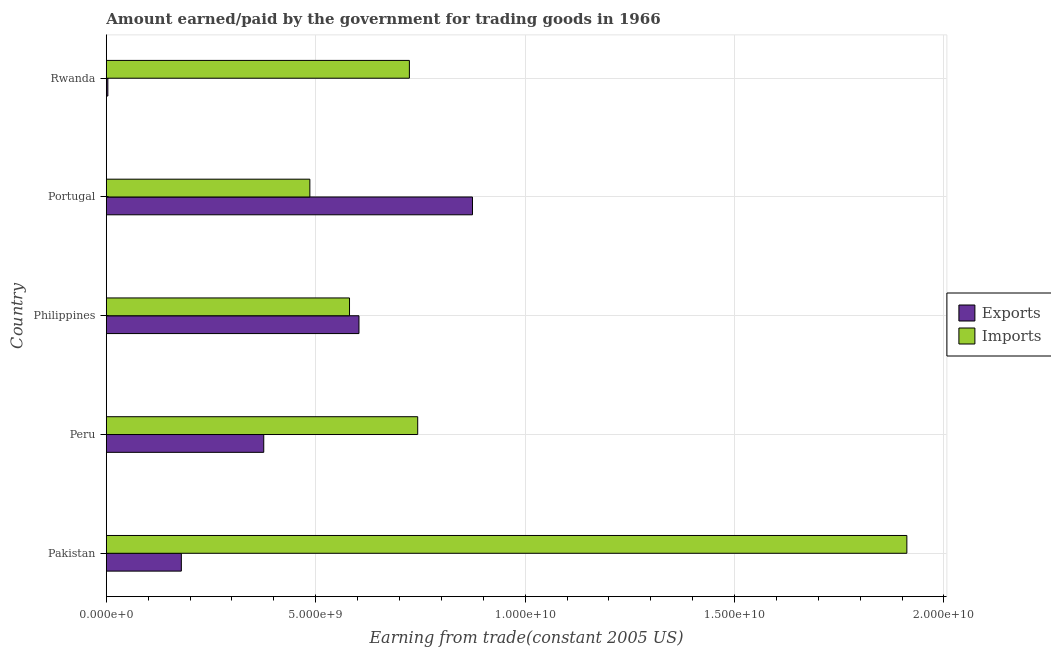How many groups of bars are there?
Your answer should be very brief. 5. Are the number of bars per tick equal to the number of legend labels?
Ensure brevity in your answer.  Yes. How many bars are there on the 5th tick from the top?
Provide a succinct answer. 2. How many bars are there on the 1st tick from the bottom?
Your answer should be very brief. 2. What is the amount paid for imports in Peru?
Ensure brevity in your answer.  7.43e+09. Across all countries, what is the maximum amount earned from exports?
Your answer should be compact. 8.74e+09. Across all countries, what is the minimum amount paid for imports?
Make the answer very short. 4.86e+09. In which country was the amount earned from exports maximum?
Offer a terse response. Portugal. In which country was the amount earned from exports minimum?
Give a very brief answer. Rwanda. What is the total amount earned from exports in the graph?
Offer a very short reply. 2.04e+1. What is the difference between the amount paid for imports in Philippines and that in Rwanda?
Your answer should be very brief. -1.43e+09. What is the difference between the amount paid for imports in Peru and the amount earned from exports in Portugal?
Your answer should be compact. -1.31e+09. What is the average amount paid for imports per country?
Keep it short and to the point. 8.89e+09. What is the difference between the amount paid for imports and amount earned from exports in Philippines?
Your response must be concise. -2.26e+08. In how many countries, is the amount paid for imports greater than 2000000000 US$?
Provide a succinct answer. 5. What is the ratio of the amount earned from exports in Pakistan to that in Philippines?
Offer a very short reply. 0.3. What is the difference between the highest and the second highest amount earned from exports?
Offer a terse response. 2.71e+09. What is the difference between the highest and the lowest amount paid for imports?
Provide a succinct answer. 1.43e+1. In how many countries, is the amount paid for imports greater than the average amount paid for imports taken over all countries?
Provide a short and direct response. 1. Is the sum of the amount earned from exports in Peru and Philippines greater than the maximum amount paid for imports across all countries?
Provide a short and direct response. No. What does the 1st bar from the top in Pakistan represents?
Offer a very short reply. Imports. What does the 2nd bar from the bottom in Philippines represents?
Offer a terse response. Imports. How many bars are there?
Give a very brief answer. 10. Are all the bars in the graph horizontal?
Keep it short and to the point. Yes. What is the difference between two consecutive major ticks on the X-axis?
Ensure brevity in your answer.  5.00e+09. Are the values on the major ticks of X-axis written in scientific E-notation?
Give a very brief answer. Yes. Where does the legend appear in the graph?
Your response must be concise. Center right. How are the legend labels stacked?
Offer a very short reply. Vertical. What is the title of the graph?
Provide a succinct answer. Amount earned/paid by the government for trading goods in 1966. What is the label or title of the X-axis?
Offer a very short reply. Earning from trade(constant 2005 US). What is the label or title of the Y-axis?
Ensure brevity in your answer.  Country. What is the Earning from trade(constant 2005 US) in Exports in Pakistan?
Offer a very short reply. 1.79e+09. What is the Earning from trade(constant 2005 US) in Imports in Pakistan?
Offer a very short reply. 1.91e+1. What is the Earning from trade(constant 2005 US) in Exports in Peru?
Your response must be concise. 3.76e+09. What is the Earning from trade(constant 2005 US) of Imports in Peru?
Ensure brevity in your answer.  7.43e+09. What is the Earning from trade(constant 2005 US) of Exports in Philippines?
Ensure brevity in your answer.  6.03e+09. What is the Earning from trade(constant 2005 US) of Imports in Philippines?
Your answer should be very brief. 5.81e+09. What is the Earning from trade(constant 2005 US) of Exports in Portugal?
Give a very brief answer. 8.74e+09. What is the Earning from trade(constant 2005 US) in Imports in Portugal?
Provide a succinct answer. 4.86e+09. What is the Earning from trade(constant 2005 US) in Exports in Rwanda?
Keep it short and to the point. 3.65e+07. What is the Earning from trade(constant 2005 US) in Imports in Rwanda?
Offer a terse response. 7.24e+09. Across all countries, what is the maximum Earning from trade(constant 2005 US) of Exports?
Your response must be concise. 8.74e+09. Across all countries, what is the maximum Earning from trade(constant 2005 US) in Imports?
Your answer should be compact. 1.91e+1. Across all countries, what is the minimum Earning from trade(constant 2005 US) in Exports?
Provide a succinct answer. 3.65e+07. Across all countries, what is the minimum Earning from trade(constant 2005 US) of Imports?
Ensure brevity in your answer.  4.86e+09. What is the total Earning from trade(constant 2005 US) in Exports in the graph?
Ensure brevity in your answer.  2.04e+1. What is the total Earning from trade(constant 2005 US) in Imports in the graph?
Ensure brevity in your answer.  4.45e+1. What is the difference between the Earning from trade(constant 2005 US) of Exports in Pakistan and that in Peru?
Provide a succinct answer. -1.97e+09. What is the difference between the Earning from trade(constant 2005 US) in Imports in Pakistan and that in Peru?
Provide a succinct answer. 1.17e+1. What is the difference between the Earning from trade(constant 2005 US) in Exports in Pakistan and that in Philippines?
Offer a terse response. -4.24e+09. What is the difference between the Earning from trade(constant 2005 US) in Imports in Pakistan and that in Philippines?
Your response must be concise. 1.33e+1. What is the difference between the Earning from trade(constant 2005 US) of Exports in Pakistan and that in Portugal?
Give a very brief answer. -6.95e+09. What is the difference between the Earning from trade(constant 2005 US) in Imports in Pakistan and that in Portugal?
Offer a very short reply. 1.43e+1. What is the difference between the Earning from trade(constant 2005 US) of Exports in Pakistan and that in Rwanda?
Ensure brevity in your answer.  1.75e+09. What is the difference between the Earning from trade(constant 2005 US) in Imports in Pakistan and that in Rwanda?
Give a very brief answer. 1.19e+1. What is the difference between the Earning from trade(constant 2005 US) in Exports in Peru and that in Philippines?
Offer a terse response. -2.27e+09. What is the difference between the Earning from trade(constant 2005 US) in Imports in Peru and that in Philippines?
Provide a short and direct response. 1.63e+09. What is the difference between the Earning from trade(constant 2005 US) in Exports in Peru and that in Portugal?
Provide a short and direct response. -4.98e+09. What is the difference between the Earning from trade(constant 2005 US) of Imports in Peru and that in Portugal?
Offer a terse response. 2.57e+09. What is the difference between the Earning from trade(constant 2005 US) of Exports in Peru and that in Rwanda?
Your answer should be compact. 3.72e+09. What is the difference between the Earning from trade(constant 2005 US) of Imports in Peru and that in Rwanda?
Provide a succinct answer. 1.98e+08. What is the difference between the Earning from trade(constant 2005 US) in Exports in Philippines and that in Portugal?
Your answer should be very brief. -2.71e+09. What is the difference between the Earning from trade(constant 2005 US) of Imports in Philippines and that in Portugal?
Your answer should be very brief. 9.47e+08. What is the difference between the Earning from trade(constant 2005 US) of Exports in Philippines and that in Rwanda?
Offer a terse response. 6.00e+09. What is the difference between the Earning from trade(constant 2005 US) of Imports in Philippines and that in Rwanda?
Ensure brevity in your answer.  -1.43e+09. What is the difference between the Earning from trade(constant 2005 US) in Exports in Portugal and that in Rwanda?
Your answer should be compact. 8.71e+09. What is the difference between the Earning from trade(constant 2005 US) of Imports in Portugal and that in Rwanda?
Offer a very short reply. -2.38e+09. What is the difference between the Earning from trade(constant 2005 US) of Exports in Pakistan and the Earning from trade(constant 2005 US) of Imports in Peru?
Keep it short and to the point. -5.64e+09. What is the difference between the Earning from trade(constant 2005 US) in Exports in Pakistan and the Earning from trade(constant 2005 US) in Imports in Philippines?
Your answer should be compact. -4.02e+09. What is the difference between the Earning from trade(constant 2005 US) in Exports in Pakistan and the Earning from trade(constant 2005 US) in Imports in Portugal?
Your answer should be very brief. -3.07e+09. What is the difference between the Earning from trade(constant 2005 US) of Exports in Pakistan and the Earning from trade(constant 2005 US) of Imports in Rwanda?
Offer a very short reply. -5.45e+09. What is the difference between the Earning from trade(constant 2005 US) of Exports in Peru and the Earning from trade(constant 2005 US) of Imports in Philippines?
Ensure brevity in your answer.  -2.05e+09. What is the difference between the Earning from trade(constant 2005 US) of Exports in Peru and the Earning from trade(constant 2005 US) of Imports in Portugal?
Give a very brief answer. -1.10e+09. What is the difference between the Earning from trade(constant 2005 US) of Exports in Peru and the Earning from trade(constant 2005 US) of Imports in Rwanda?
Your response must be concise. -3.48e+09. What is the difference between the Earning from trade(constant 2005 US) in Exports in Philippines and the Earning from trade(constant 2005 US) in Imports in Portugal?
Keep it short and to the point. 1.17e+09. What is the difference between the Earning from trade(constant 2005 US) in Exports in Philippines and the Earning from trade(constant 2005 US) in Imports in Rwanda?
Ensure brevity in your answer.  -1.20e+09. What is the difference between the Earning from trade(constant 2005 US) of Exports in Portugal and the Earning from trade(constant 2005 US) of Imports in Rwanda?
Provide a succinct answer. 1.51e+09. What is the average Earning from trade(constant 2005 US) in Exports per country?
Your answer should be compact. 4.07e+09. What is the average Earning from trade(constant 2005 US) of Imports per country?
Your response must be concise. 8.89e+09. What is the difference between the Earning from trade(constant 2005 US) in Exports and Earning from trade(constant 2005 US) in Imports in Pakistan?
Offer a terse response. -1.73e+1. What is the difference between the Earning from trade(constant 2005 US) in Exports and Earning from trade(constant 2005 US) in Imports in Peru?
Provide a succinct answer. -3.68e+09. What is the difference between the Earning from trade(constant 2005 US) of Exports and Earning from trade(constant 2005 US) of Imports in Philippines?
Your response must be concise. 2.26e+08. What is the difference between the Earning from trade(constant 2005 US) in Exports and Earning from trade(constant 2005 US) in Imports in Portugal?
Make the answer very short. 3.88e+09. What is the difference between the Earning from trade(constant 2005 US) in Exports and Earning from trade(constant 2005 US) in Imports in Rwanda?
Offer a very short reply. -7.20e+09. What is the ratio of the Earning from trade(constant 2005 US) of Exports in Pakistan to that in Peru?
Keep it short and to the point. 0.48. What is the ratio of the Earning from trade(constant 2005 US) in Imports in Pakistan to that in Peru?
Offer a terse response. 2.57. What is the ratio of the Earning from trade(constant 2005 US) in Exports in Pakistan to that in Philippines?
Keep it short and to the point. 0.3. What is the ratio of the Earning from trade(constant 2005 US) of Imports in Pakistan to that in Philippines?
Your answer should be compact. 3.29. What is the ratio of the Earning from trade(constant 2005 US) in Exports in Pakistan to that in Portugal?
Your answer should be very brief. 0.2. What is the ratio of the Earning from trade(constant 2005 US) of Imports in Pakistan to that in Portugal?
Give a very brief answer. 3.93. What is the ratio of the Earning from trade(constant 2005 US) in Exports in Pakistan to that in Rwanda?
Provide a short and direct response. 49.1. What is the ratio of the Earning from trade(constant 2005 US) of Imports in Pakistan to that in Rwanda?
Keep it short and to the point. 2.64. What is the ratio of the Earning from trade(constant 2005 US) in Exports in Peru to that in Philippines?
Offer a very short reply. 0.62. What is the ratio of the Earning from trade(constant 2005 US) in Imports in Peru to that in Philippines?
Your response must be concise. 1.28. What is the ratio of the Earning from trade(constant 2005 US) of Exports in Peru to that in Portugal?
Keep it short and to the point. 0.43. What is the ratio of the Earning from trade(constant 2005 US) in Imports in Peru to that in Portugal?
Offer a terse response. 1.53. What is the ratio of the Earning from trade(constant 2005 US) in Exports in Peru to that in Rwanda?
Offer a very short reply. 103.03. What is the ratio of the Earning from trade(constant 2005 US) of Imports in Peru to that in Rwanda?
Provide a short and direct response. 1.03. What is the ratio of the Earning from trade(constant 2005 US) in Exports in Philippines to that in Portugal?
Your response must be concise. 0.69. What is the ratio of the Earning from trade(constant 2005 US) of Imports in Philippines to that in Portugal?
Make the answer very short. 1.19. What is the ratio of the Earning from trade(constant 2005 US) in Exports in Philippines to that in Rwanda?
Offer a very short reply. 165.36. What is the ratio of the Earning from trade(constant 2005 US) in Imports in Philippines to that in Rwanda?
Your response must be concise. 0.8. What is the ratio of the Earning from trade(constant 2005 US) in Exports in Portugal to that in Rwanda?
Provide a succinct answer. 239.65. What is the ratio of the Earning from trade(constant 2005 US) in Imports in Portugal to that in Rwanda?
Your answer should be very brief. 0.67. What is the difference between the highest and the second highest Earning from trade(constant 2005 US) in Exports?
Your answer should be very brief. 2.71e+09. What is the difference between the highest and the second highest Earning from trade(constant 2005 US) of Imports?
Make the answer very short. 1.17e+1. What is the difference between the highest and the lowest Earning from trade(constant 2005 US) of Exports?
Provide a short and direct response. 8.71e+09. What is the difference between the highest and the lowest Earning from trade(constant 2005 US) in Imports?
Your response must be concise. 1.43e+1. 